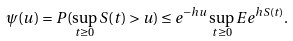Convert formula to latex. <formula><loc_0><loc_0><loc_500><loc_500>\psi ( u ) = { P } ( \sup _ { t \geq 0 } S ( t ) > u ) \leq e ^ { - h u } \sup _ { t \geq 0 } { E } e ^ { h S ( t ) } .</formula> 